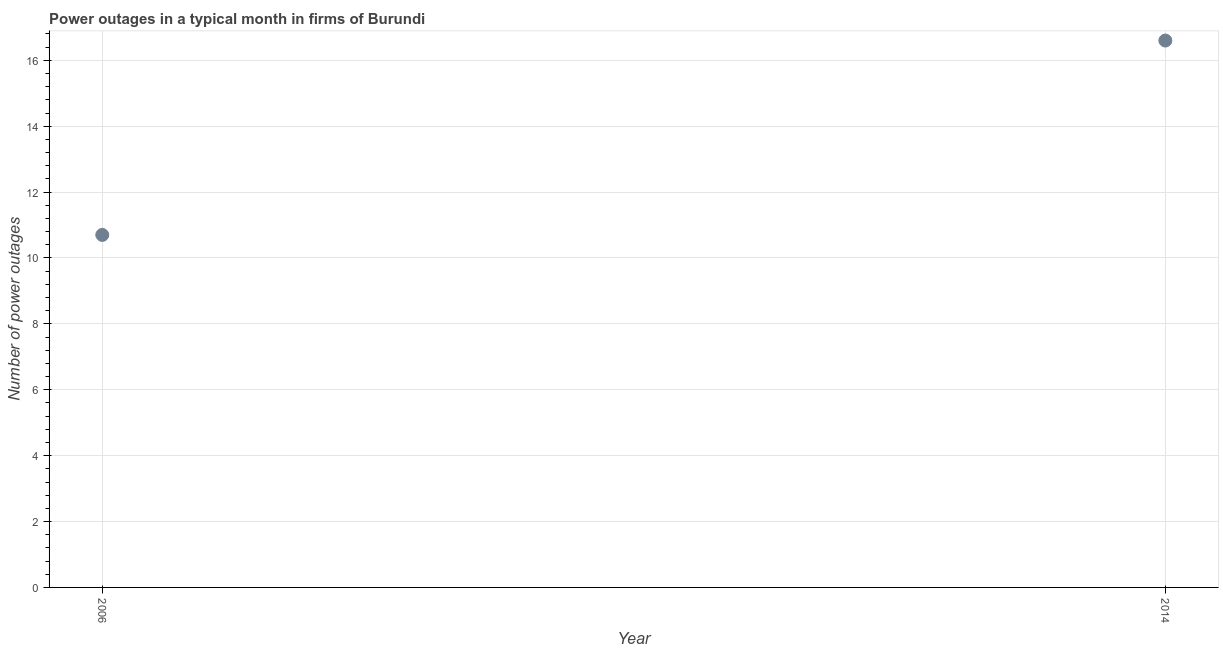What is the number of power outages in 2006?
Give a very brief answer. 10.7. Across all years, what is the minimum number of power outages?
Ensure brevity in your answer.  10.7. In which year was the number of power outages maximum?
Your response must be concise. 2014. In which year was the number of power outages minimum?
Give a very brief answer. 2006. What is the sum of the number of power outages?
Your answer should be very brief. 27.3. What is the difference between the number of power outages in 2006 and 2014?
Offer a terse response. -5.9. What is the average number of power outages per year?
Offer a terse response. 13.65. What is the median number of power outages?
Give a very brief answer. 13.65. What is the ratio of the number of power outages in 2006 to that in 2014?
Make the answer very short. 0.64. Is the number of power outages in 2006 less than that in 2014?
Ensure brevity in your answer.  Yes. Does the number of power outages monotonically increase over the years?
Your response must be concise. Yes. How many dotlines are there?
Your answer should be compact. 1. How many years are there in the graph?
Your response must be concise. 2. What is the difference between two consecutive major ticks on the Y-axis?
Provide a succinct answer. 2. Are the values on the major ticks of Y-axis written in scientific E-notation?
Provide a short and direct response. No. Does the graph contain grids?
Give a very brief answer. Yes. What is the title of the graph?
Keep it short and to the point. Power outages in a typical month in firms of Burundi. What is the label or title of the X-axis?
Provide a succinct answer. Year. What is the label or title of the Y-axis?
Your answer should be very brief. Number of power outages. What is the Number of power outages in 2006?
Ensure brevity in your answer.  10.7. What is the Number of power outages in 2014?
Your answer should be compact. 16.6. What is the difference between the Number of power outages in 2006 and 2014?
Provide a short and direct response. -5.9. What is the ratio of the Number of power outages in 2006 to that in 2014?
Your answer should be very brief. 0.65. 